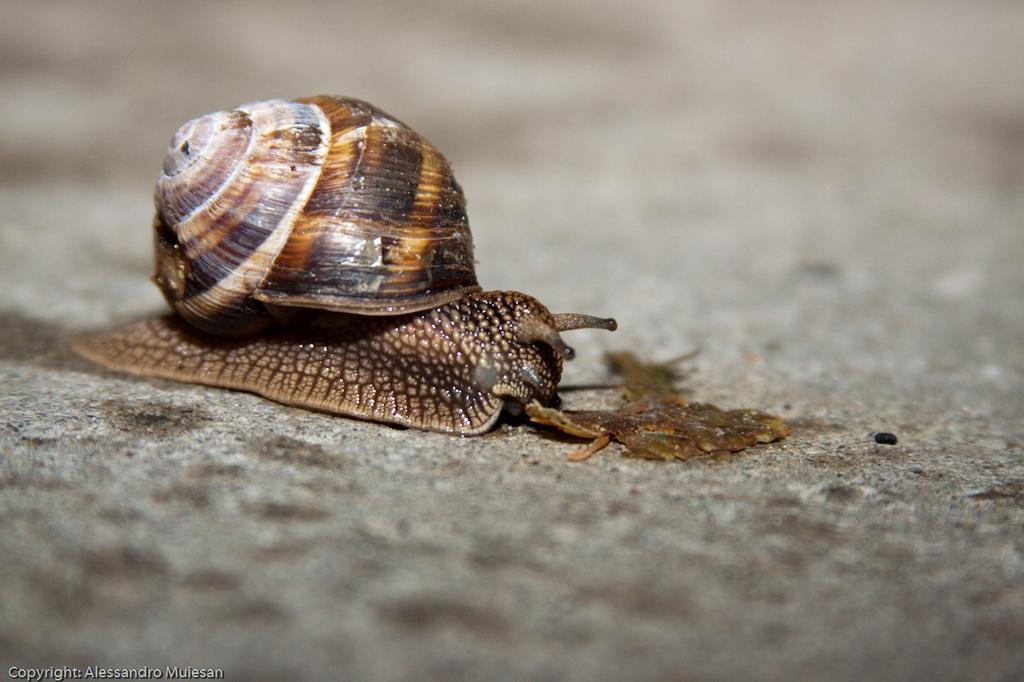How would you summarize this image in a sentence or two? In this image, we can see a snail on the surface. 